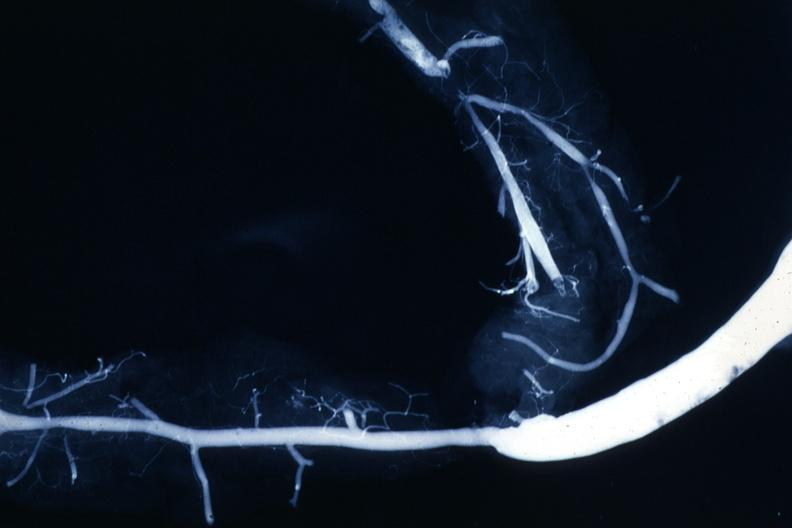s this image shows of smooth muscle cell with lipid in sarcoplasm and lipid present?
Answer the question using a single word or phrase. No 